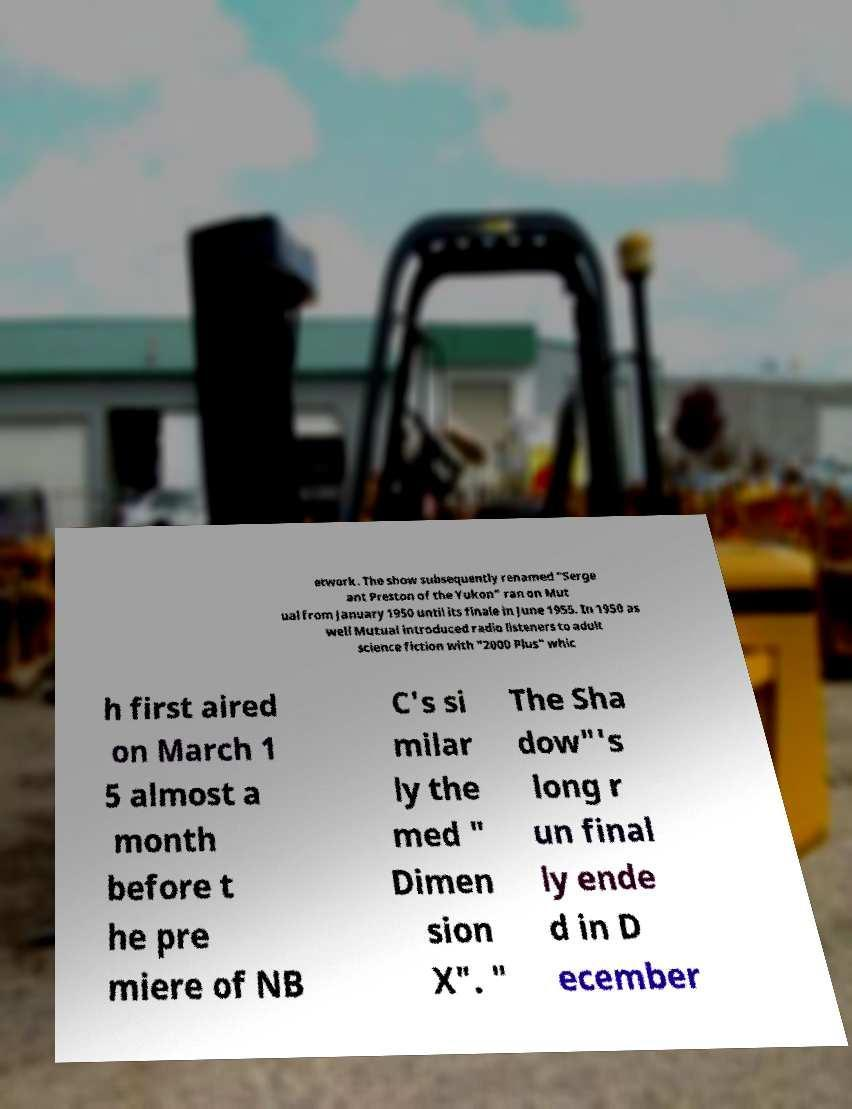Can you accurately transcribe the text from the provided image for me? etwork. The show subsequently renamed "Serge ant Preston of the Yukon" ran on Mut ual from January 1950 until its finale in June 1955. In 1950 as well Mutual introduced radio listeners to adult science fiction with "2000 Plus" whic h first aired on March 1 5 almost a month before t he pre miere of NB C's si milar ly the med " Dimen sion X". " The Sha dow"'s long r un final ly ende d in D ecember 